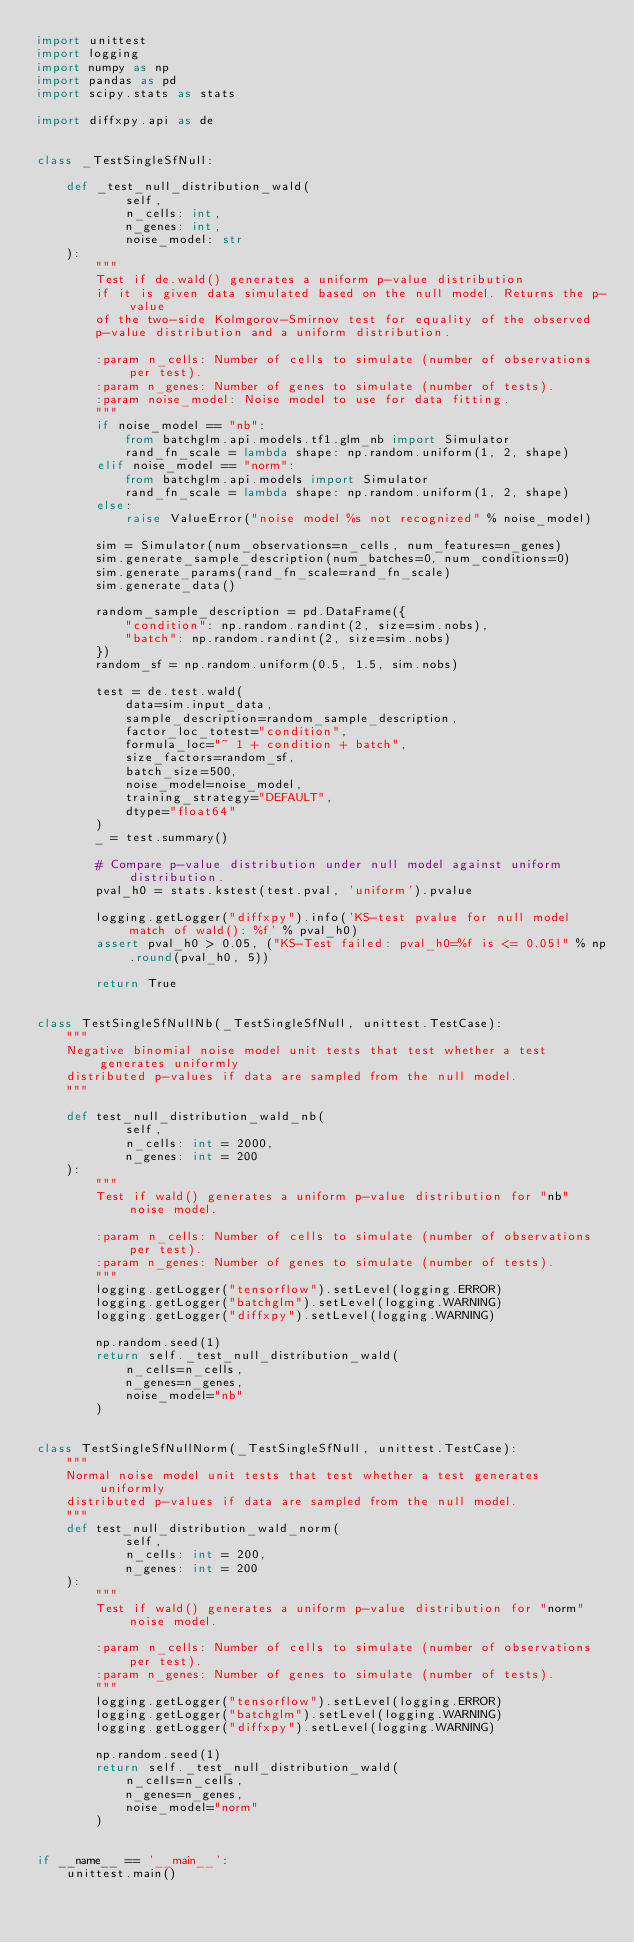<code> <loc_0><loc_0><loc_500><loc_500><_Python_>import unittest
import logging
import numpy as np
import pandas as pd
import scipy.stats as stats

import diffxpy.api as de


class _TestSingleSfNull:

    def _test_null_distribution_wald(
            self,
            n_cells: int,
            n_genes: int,
            noise_model: str
    ):
        """
        Test if de.wald() generates a uniform p-value distribution
        if it is given data simulated based on the null model. Returns the p-value
        of the two-side Kolmgorov-Smirnov test for equality of the observed 
        p-value distribution and a uniform distribution.

        :param n_cells: Number of cells to simulate (number of observations per test).
        :param n_genes: Number of genes to simulate (number of tests).
        :param noise_model: Noise model to use for data fitting.
        """
        if noise_model == "nb":
            from batchglm.api.models.tf1.glm_nb import Simulator
            rand_fn_scale = lambda shape: np.random.uniform(1, 2, shape)
        elif noise_model == "norm":
            from batchglm.api.models import Simulator
            rand_fn_scale = lambda shape: np.random.uniform(1, 2, shape)
        else:
            raise ValueError("noise model %s not recognized" % noise_model)

        sim = Simulator(num_observations=n_cells, num_features=n_genes)
        sim.generate_sample_description(num_batches=0, num_conditions=0)
        sim.generate_params(rand_fn_scale=rand_fn_scale)
        sim.generate_data()

        random_sample_description = pd.DataFrame({
            "condition": np.random.randint(2, size=sim.nobs),
            "batch": np.random.randint(2, size=sim.nobs)
        })
        random_sf = np.random.uniform(0.5, 1.5, sim.nobs)

        test = de.test.wald(
            data=sim.input_data,
            sample_description=random_sample_description,
            factor_loc_totest="condition",
            formula_loc="~ 1 + condition + batch",
            size_factors=random_sf,
            batch_size=500,
            noise_model=noise_model,
            training_strategy="DEFAULT",
            dtype="float64"
        )
        _ = test.summary()

        # Compare p-value distribution under null model against uniform distribution.
        pval_h0 = stats.kstest(test.pval, 'uniform').pvalue

        logging.getLogger("diffxpy").info('KS-test pvalue for null model match of wald(): %f' % pval_h0)
        assert pval_h0 > 0.05, ("KS-Test failed: pval_h0=%f is <= 0.05!" % np.round(pval_h0, 5))

        return True


class TestSingleSfNullNb(_TestSingleSfNull, unittest.TestCase):
    """
    Negative binomial noise model unit tests that test whether a test generates uniformly
    distributed p-values if data are sampled from the null model.
    """

    def test_null_distribution_wald_nb(
            self,
            n_cells: int = 2000,
            n_genes: int = 200
    ):
        """
        Test if wald() generates a uniform p-value distribution for "nb" noise model.

        :param n_cells: Number of cells to simulate (number of observations per test).
        :param n_genes: Number of genes to simulate (number of tests).
        """
        logging.getLogger("tensorflow").setLevel(logging.ERROR)
        logging.getLogger("batchglm").setLevel(logging.WARNING)
        logging.getLogger("diffxpy").setLevel(logging.WARNING)

        np.random.seed(1)
        return self._test_null_distribution_wald(
            n_cells=n_cells,
            n_genes=n_genes,
            noise_model="nb"
        )


class TestSingleSfNullNorm(_TestSingleSfNull, unittest.TestCase):
    """
    Normal noise model unit tests that test whether a test generates uniformly
    distributed p-values if data are sampled from the null model.
    """
    def test_null_distribution_wald_norm(
            self,
            n_cells: int = 200,
            n_genes: int = 200
    ):
        """
        Test if wald() generates a uniform p-value distribution for "norm" noise model.

        :param n_cells: Number of cells to simulate (number of observations per test).
        :param n_genes: Number of genes to simulate (number of tests).
        """
        logging.getLogger("tensorflow").setLevel(logging.ERROR)
        logging.getLogger("batchglm").setLevel(logging.WARNING)
        logging.getLogger("diffxpy").setLevel(logging.WARNING)

        np.random.seed(1)
        return self._test_null_distribution_wald(
            n_cells=n_cells,
            n_genes=n_genes,
            noise_model="norm"
        )


if __name__ == '__main__':
    unittest.main()
</code> 